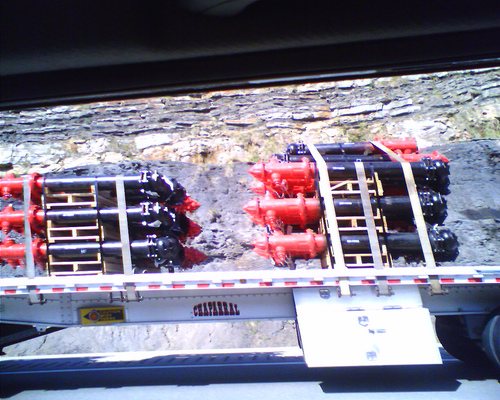<image>What is the trailer attached to? I am not sure what the trailer is attached to. It may be attached to a truck. Which local department needs the contents of this trailer? It is unknown which local department needs the contents of this trailer. It could be the Fire department, Police, Gas Company or Forensics. What is the trailer attached to? I am not sure what the trailer is attached to. It can be attached to a truck or some other object. Which local department needs the contents of this trailer? It is uncertain which local department needs the contents of this trailer. It can be the fire department, gas company, police, or forensics. 